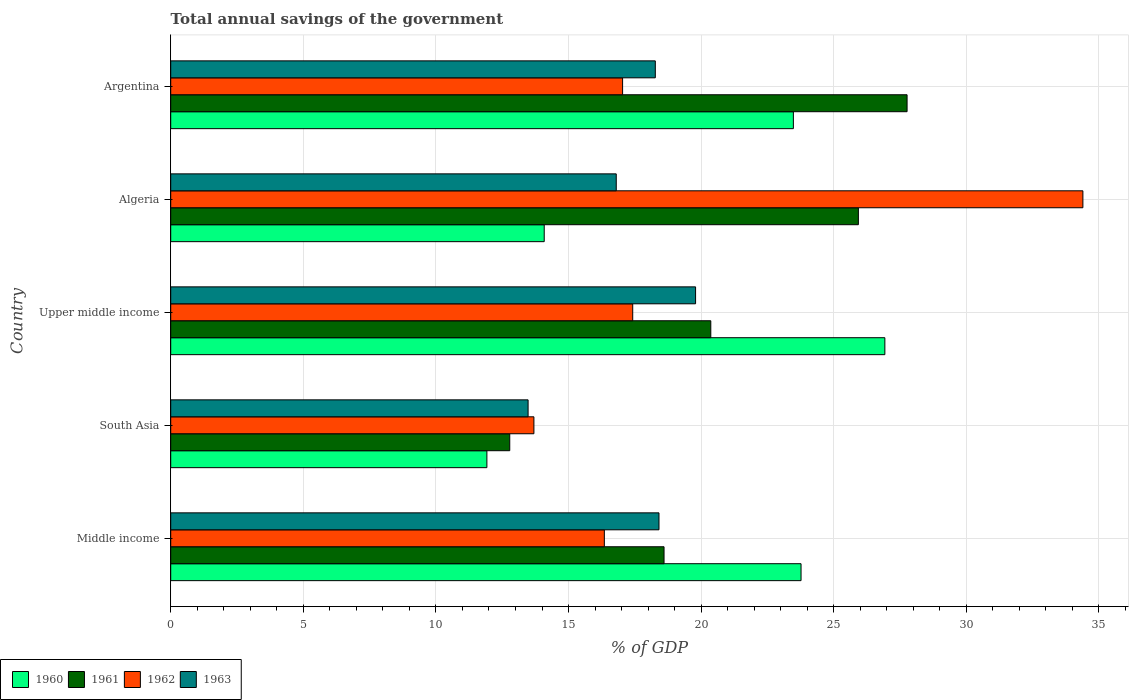Are the number of bars on each tick of the Y-axis equal?
Make the answer very short. Yes. How many bars are there on the 3rd tick from the top?
Give a very brief answer. 4. How many bars are there on the 4th tick from the bottom?
Your answer should be very brief. 4. What is the label of the 3rd group of bars from the top?
Your answer should be very brief. Upper middle income. What is the total annual savings of the government in 1961 in Upper middle income?
Offer a very short reply. 20.37. Across all countries, what is the maximum total annual savings of the government in 1961?
Make the answer very short. 27.77. Across all countries, what is the minimum total annual savings of the government in 1962?
Your answer should be compact. 13.69. In which country was the total annual savings of the government in 1960 maximum?
Offer a very short reply. Upper middle income. In which country was the total annual savings of the government in 1963 minimum?
Give a very brief answer. South Asia. What is the total total annual savings of the government in 1962 in the graph?
Keep it short and to the point. 98.9. What is the difference between the total annual savings of the government in 1963 in Algeria and that in Argentina?
Give a very brief answer. -1.47. What is the difference between the total annual savings of the government in 1963 in South Asia and the total annual savings of the government in 1962 in Middle income?
Keep it short and to the point. -2.88. What is the average total annual savings of the government in 1961 per country?
Provide a succinct answer. 21.09. What is the difference between the total annual savings of the government in 1960 and total annual savings of the government in 1961 in Upper middle income?
Your answer should be compact. 6.56. In how many countries, is the total annual savings of the government in 1960 greater than 7 %?
Offer a terse response. 5. What is the ratio of the total annual savings of the government in 1963 in Argentina to that in Middle income?
Make the answer very short. 0.99. Is the total annual savings of the government in 1961 in Algeria less than that in Middle income?
Ensure brevity in your answer.  No. What is the difference between the highest and the second highest total annual savings of the government in 1962?
Offer a very short reply. 16.97. What is the difference between the highest and the lowest total annual savings of the government in 1961?
Give a very brief answer. 14.98. In how many countries, is the total annual savings of the government in 1962 greater than the average total annual savings of the government in 1962 taken over all countries?
Make the answer very short. 1. Is the sum of the total annual savings of the government in 1963 in Argentina and Middle income greater than the maximum total annual savings of the government in 1962 across all countries?
Ensure brevity in your answer.  Yes. What does the 3rd bar from the top in Upper middle income represents?
Provide a short and direct response. 1961. Is it the case that in every country, the sum of the total annual savings of the government in 1960 and total annual savings of the government in 1963 is greater than the total annual savings of the government in 1962?
Your response must be concise. No. How many countries are there in the graph?
Your response must be concise. 5. Are the values on the major ticks of X-axis written in scientific E-notation?
Give a very brief answer. No. Does the graph contain any zero values?
Your response must be concise. No. Does the graph contain grids?
Your response must be concise. Yes. Where does the legend appear in the graph?
Offer a terse response. Bottom left. What is the title of the graph?
Make the answer very short. Total annual savings of the government. What is the label or title of the X-axis?
Your answer should be compact. % of GDP. What is the % of GDP in 1960 in Middle income?
Your response must be concise. 23.77. What is the % of GDP of 1961 in Middle income?
Your answer should be very brief. 18.6. What is the % of GDP of 1962 in Middle income?
Offer a terse response. 16.35. What is the % of GDP in 1963 in Middle income?
Give a very brief answer. 18.41. What is the % of GDP in 1960 in South Asia?
Keep it short and to the point. 11.92. What is the % of GDP in 1961 in South Asia?
Keep it short and to the point. 12.78. What is the % of GDP in 1962 in South Asia?
Ensure brevity in your answer.  13.69. What is the % of GDP of 1963 in South Asia?
Your response must be concise. 13.48. What is the % of GDP of 1960 in Upper middle income?
Your answer should be very brief. 26.93. What is the % of GDP in 1961 in Upper middle income?
Offer a terse response. 20.37. What is the % of GDP in 1962 in Upper middle income?
Your response must be concise. 17.42. What is the % of GDP of 1963 in Upper middle income?
Ensure brevity in your answer.  19.79. What is the % of GDP of 1960 in Algeria?
Keep it short and to the point. 14.08. What is the % of GDP in 1961 in Algeria?
Provide a succinct answer. 25.93. What is the % of GDP of 1962 in Algeria?
Your answer should be very brief. 34.4. What is the % of GDP of 1963 in Algeria?
Offer a terse response. 16.8. What is the % of GDP in 1960 in Argentina?
Keep it short and to the point. 23.48. What is the % of GDP in 1961 in Argentina?
Your answer should be compact. 27.77. What is the % of GDP in 1962 in Argentina?
Make the answer very short. 17.04. What is the % of GDP of 1963 in Argentina?
Give a very brief answer. 18.27. Across all countries, what is the maximum % of GDP of 1960?
Give a very brief answer. 26.93. Across all countries, what is the maximum % of GDP in 1961?
Your answer should be compact. 27.77. Across all countries, what is the maximum % of GDP in 1962?
Your response must be concise. 34.4. Across all countries, what is the maximum % of GDP of 1963?
Offer a terse response. 19.79. Across all countries, what is the minimum % of GDP in 1960?
Offer a very short reply. 11.92. Across all countries, what is the minimum % of GDP of 1961?
Give a very brief answer. 12.78. Across all countries, what is the minimum % of GDP in 1962?
Offer a very short reply. 13.69. Across all countries, what is the minimum % of GDP in 1963?
Your response must be concise. 13.48. What is the total % of GDP of 1960 in the graph?
Keep it short and to the point. 100.18. What is the total % of GDP of 1961 in the graph?
Give a very brief answer. 105.45. What is the total % of GDP of 1962 in the graph?
Provide a succinct answer. 98.9. What is the total % of GDP in 1963 in the graph?
Make the answer very short. 86.75. What is the difference between the % of GDP of 1960 in Middle income and that in South Asia?
Ensure brevity in your answer.  11.85. What is the difference between the % of GDP in 1961 in Middle income and that in South Asia?
Offer a very short reply. 5.82. What is the difference between the % of GDP in 1962 in Middle income and that in South Asia?
Offer a terse response. 2.66. What is the difference between the % of GDP of 1963 in Middle income and that in South Asia?
Your answer should be compact. 4.94. What is the difference between the % of GDP in 1960 in Middle income and that in Upper middle income?
Keep it short and to the point. -3.16. What is the difference between the % of GDP of 1961 in Middle income and that in Upper middle income?
Keep it short and to the point. -1.76. What is the difference between the % of GDP of 1962 in Middle income and that in Upper middle income?
Make the answer very short. -1.07. What is the difference between the % of GDP in 1963 in Middle income and that in Upper middle income?
Provide a short and direct response. -1.38. What is the difference between the % of GDP in 1960 in Middle income and that in Algeria?
Your answer should be compact. 9.68. What is the difference between the % of GDP of 1961 in Middle income and that in Algeria?
Offer a very short reply. -7.33. What is the difference between the % of GDP in 1962 in Middle income and that in Algeria?
Offer a very short reply. -18.05. What is the difference between the % of GDP of 1963 in Middle income and that in Algeria?
Offer a very short reply. 1.61. What is the difference between the % of GDP of 1960 in Middle income and that in Argentina?
Offer a terse response. 0.29. What is the difference between the % of GDP of 1961 in Middle income and that in Argentina?
Offer a very short reply. -9.16. What is the difference between the % of GDP of 1962 in Middle income and that in Argentina?
Your response must be concise. -0.69. What is the difference between the % of GDP in 1963 in Middle income and that in Argentina?
Your response must be concise. 0.14. What is the difference between the % of GDP of 1960 in South Asia and that in Upper middle income?
Your answer should be compact. -15.01. What is the difference between the % of GDP of 1961 in South Asia and that in Upper middle income?
Offer a very short reply. -7.58. What is the difference between the % of GDP of 1962 in South Asia and that in Upper middle income?
Your answer should be compact. -3.73. What is the difference between the % of GDP in 1963 in South Asia and that in Upper middle income?
Offer a terse response. -6.32. What is the difference between the % of GDP in 1960 in South Asia and that in Algeria?
Keep it short and to the point. -2.16. What is the difference between the % of GDP of 1961 in South Asia and that in Algeria?
Your response must be concise. -13.15. What is the difference between the % of GDP of 1962 in South Asia and that in Algeria?
Your answer should be compact. -20.7. What is the difference between the % of GDP of 1963 in South Asia and that in Algeria?
Ensure brevity in your answer.  -3.32. What is the difference between the % of GDP in 1960 in South Asia and that in Argentina?
Your answer should be very brief. -11.56. What is the difference between the % of GDP of 1961 in South Asia and that in Argentina?
Provide a succinct answer. -14.98. What is the difference between the % of GDP in 1962 in South Asia and that in Argentina?
Provide a short and direct response. -3.34. What is the difference between the % of GDP in 1963 in South Asia and that in Argentina?
Give a very brief answer. -4.8. What is the difference between the % of GDP of 1960 in Upper middle income and that in Algeria?
Make the answer very short. 12.84. What is the difference between the % of GDP of 1961 in Upper middle income and that in Algeria?
Keep it short and to the point. -5.57. What is the difference between the % of GDP in 1962 in Upper middle income and that in Algeria?
Keep it short and to the point. -16.97. What is the difference between the % of GDP in 1963 in Upper middle income and that in Algeria?
Your answer should be compact. 2.99. What is the difference between the % of GDP in 1960 in Upper middle income and that in Argentina?
Provide a short and direct response. 3.45. What is the difference between the % of GDP in 1961 in Upper middle income and that in Argentina?
Provide a succinct answer. -7.4. What is the difference between the % of GDP in 1962 in Upper middle income and that in Argentina?
Your response must be concise. 0.38. What is the difference between the % of GDP of 1963 in Upper middle income and that in Argentina?
Provide a short and direct response. 1.52. What is the difference between the % of GDP of 1960 in Algeria and that in Argentina?
Offer a terse response. -9.4. What is the difference between the % of GDP in 1961 in Algeria and that in Argentina?
Make the answer very short. -1.84. What is the difference between the % of GDP of 1962 in Algeria and that in Argentina?
Provide a short and direct response. 17.36. What is the difference between the % of GDP of 1963 in Algeria and that in Argentina?
Ensure brevity in your answer.  -1.47. What is the difference between the % of GDP in 1960 in Middle income and the % of GDP in 1961 in South Asia?
Your response must be concise. 10.98. What is the difference between the % of GDP in 1960 in Middle income and the % of GDP in 1962 in South Asia?
Provide a short and direct response. 10.07. What is the difference between the % of GDP in 1960 in Middle income and the % of GDP in 1963 in South Asia?
Your answer should be compact. 10.29. What is the difference between the % of GDP in 1961 in Middle income and the % of GDP in 1962 in South Asia?
Your response must be concise. 4.91. What is the difference between the % of GDP of 1961 in Middle income and the % of GDP of 1963 in South Asia?
Keep it short and to the point. 5.13. What is the difference between the % of GDP in 1962 in Middle income and the % of GDP in 1963 in South Asia?
Provide a succinct answer. 2.88. What is the difference between the % of GDP of 1960 in Middle income and the % of GDP of 1961 in Upper middle income?
Provide a succinct answer. 3.4. What is the difference between the % of GDP of 1960 in Middle income and the % of GDP of 1962 in Upper middle income?
Offer a terse response. 6.35. What is the difference between the % of GDP of 1960 in Middle income and the % of GDP of 1963 in Upper middle income?
Offer a very short reply. 3.98. What is the difference between the % of GDP of 1961 in Middle income and the % of GDP of 1962 in Upper middle income?
Provide a short and direct response. 1.18. What is the difference between the % of GDP in 1961 in Middle income and the % of GDP in 1963 in Upper middle income?
Your answer should be very brief. -1.19. What is the difference between the % of GDP of 1962 in Middle income and the % of GDP of 1963 in Upper middle income?
Your response must be concise. -3.44. What is the difference between the % of GDP in 1960 in Middle income and the % of GDP in 1961 in Algeria?
Make the answer very short. -2.16. What is the difference between the % of GDP in 1960 in Middle income and the % of GDP in 1962 in Algeria?
Give a very brief answer. -10.63. What is the difference between the % of GDP in 1960 in Middle income and the % of GDP in 1963 in Algeria?
Offer a very short reply. 6.97. What is the difference between the % of GDP of 1961 in Middle income and the % of GDP of 1962 in Algeria?
Offer a very short reply. -15.79. What is the difference between the % of GDP in 1961 in Middle income and the % of GDP in 1963 in Algeria?
Provide a succinct answer. 1.8. What is the difference between the % of GDP in 1962 in Middle income and the % of GDP in 1963 in Algeria?
Offer a very short reply. -0.45. What is the difference between the % of GDP of 1960 in Middle income and the % of GDP of 1961 in Argentina?
Provide a succinct answer. -4. What is the difference between the % of GDP of 1960 in Middle income and the % of GDP of 1962 in Argentina?
Provide a short and direct response. 6.73. What is the difference between the % of GDP of 1960 in Middle income and the % of GDP of 1963 in Argentina?
Offer a terse response. 5.5. What is the difference between the % of GDP of 1961 in Middle income and the % of GDP of 1962 in Argentina?
Provide a succinct answer. 1.56. What is the difference between the % of GDP of 1961 in Middle income and the % of GDP of 1963 in Argentina?
Give a very brief answer. 0.33. What is the difference between the % of GDP of 1962 in Middle income and the % of GDP of 1963 in Argentina?
Offer a very short reply. -1.92. What is the difference between the % of GDP of 1960 in South Asia and the % of GDP of 1961 in Upper middle income?
Keep it short and to the point. -8.44. What is the difference between the % of GDP of 1960 in South Asia and the % of GDP of 1962 in Upper middle income?
Your answer should be very brief. -5.5. What is the difference between the % of GDP in 1960 in South Asia and the % of GDP in 1963 in Upper middle income?
Your answer should be compact. -7.87. What is the difference between the % of GDP of 1961 in South Asia and the % of GDP of 1962 in Upper middle income?
Offer a terse response. -4.64. What is the difference between the % of GDP in 1961 in South Asia and the % of GDP in 1963 in Upper middle income?
Ensure brevity in your answer.  -7.01. What is the difference between the % of GDP of 1962 in South Asia and the % of GDP of 1963 in Upper middle income?
Provide a short and direct response. -6.1. What is the difference between the % of GDP in 1960 in South Asia and the % of GDP in 1961 in Algeria?
Provide a succinct answer. -14.01. What is the difference between the % of GDP of 1960 in South Asia and the % of GDP of 1962 in Algeria?
Your answer should be very brief. -22.47. What is the difference between the % of GDP in 1960 in South Asia and the % of GDP in 1963 in Algeria?
Provide a succinct answer. -4.88. What is the difference between the % of GDP of 1961 in South Asia and the % of GDP of 1962 in Algeria?
Your answer should be very brief. -21.61. What is the difference between the % of GDP in 1961 in South Asia and the % of GDP in 1963 in Algeria?
Your answer should be compact. -4.02. What is the difference between the % of GDP in 1962 in South Asia and the % of GDP in 1963 in Algeria?
Ensure brevity in your answer.  -3.1. What is the difference between the % of GDP in 1960 in South Asia and the % of GDP in 1961 in Argentina?
Offer a terse response. -15.84. What is the difference between the % of GDP in 1960 in South Asia and the % of GDP in 1962 in Argentina?
Ensure brevity in your answer.  -5.12. What is the difference between the % of GDP in 1960 in South Asia and the % of GDP in 1963 in Argentina?
Your answer should be compact. -6.35. What is the difference between the % of GDP in 1961 in South Asia and the % of GDP in 1962 in Argentina?
Ensure brevity in your answer.  -4.26. What is the difference between the % of GDP of 1961 in South Asia and the % of GDP of 1963 in Argentina?
Offer a terse response. -5.49. What is the difference between the % of GDP in 1962 in South Asia and the % of GDP in 1963 in Argentina?
Your answer should be very brief. -4.58. What is the difference between the % of GDP in 1960 in Upper middle income and the % of GDP in 1962 in Algeria?
Keep it short and to the point. -7.47. What is the difference between the % of GDP of 1960 in Upper middle income and the % of GDP of 1963 in Algeria?
Your answer should be very brief. 10.13. What is the difference between the % of GDP of 1961 in Upper middle income and the % of GDP of 1962 in Algeria?
Give a very brief answer. -14.03. What is the difference between the % of GDP in 1961 in Upper middle income and the % of GDP in 1963 in Algeria?
Your response must be concise. 3.57. What is the difference between the % of GDP in 1962 in Upper middle income and the % of GDP in 1963 in Algeria?
Ensure brevity in your answer.  0.62. What is the difference between the % of GDP of 1960 in Upper middle income and the % of GDP of 1961 in Argentina?
Offer a very short reply. -0.84. What is the difference between the % of GDP of 1960 in Upper middle income and the % of GDP of 1962 in Argentina?
Keep it short and to the point. 9.89. What is the difference between the % of GDP of 1960 in Upper middle income and the % of GDP of 1963 in Argentina?
Ensure brevity in your answer.  8.66. What is the difference between the % of GDP in 1961 in Upper middle income and the % of GDP in 1962 in Argentina?
Ensure brevity in your answer.  3.33. What is the difference between the % of GDP in 1961 in Upper middle income and the % of GDP in 1963 in Argentina?
Offer a terse response. 2.09. What is the difference between the % of GDP of 1962 in Upper middle income and the % of GDP of 1963 in Argentina?
Your response must be concise. -0.85. What is the difference between the % of GDP of 1960 in Algeria and the % of GDP of 1961 in Argentina?
Offer a very short reply. -13.68. What is the difference between the % of GDP in 1960 in Algeria and the % of GDP in 1962 in Argentina?
Offer a very short reply. -2.96. What is the difference between the % of GDP of 1960 in Algeria and the % of GDP of 1963 in Argentina?
Give a very brief answer. -4.19. What is the difference between the % of GDP in 1961 in Algeria and the % of GDP in 1962 in Argentina?
Give a very brief answer. 8.89. What is the difference between the % of GDP in 1961 in Algeria and the % of GDP in 1963 in Argentina?
Offer a terse response. 7.66. What is the difference between the % of GDP of 1962 in Algeria and the % of GDP of 1963 in Argentina?
Offer a terse response. 16.12. What is the average % of GDP of 1960 per country?
Offer a very short reply. 20.04. What is the average % of GDP in 1961 per country?
Your answer should be compact. 21.09. What is the average % of GDP in 1962 per country?
Your response must be concise. 19.78. What is the average % of GDP of 1963 per country?
Give a very brief answer. 17.35. What is the difference between the % of GDP of 1960 and % of GDP of 1961 in Middle income?
Give a very brief answer. 5.17. What is the difference between the % of GDP in 1960 and % of GDP in 1962 in Middle income?
Give a very brief answer. 7.42. What is the difference between the % of GDP in 1960 and % of GDP in 1963 in Middle income?
Make the answer very short. 5.36. What is the difference between the % of GDP of 1961 and % of GDP of 1962 in Middle income?
Offer a terse response. 2.25. What is the difference between the % of GDP in 1961 and % of GDP in 1963 in Middle income?
Ensure brevity in your answer.  0.19. What is the difference between the % of GDP in 1962 and % of GDP in 1963 in Middle income?
Give a very brief answer. -2.06. What is the difference between the % of GDP of 1960 and % of GDP of 1961 in South Asia?
Give a very brief answer. -0.86. What is the difference between the % of GDP in 1960 and % of GDP in 1962 in South Asia?
Your response must be concise. -1.77. What is the difference between the % of GDP of 1960 and % of GDP of 1963 in South Asia?
Provide a succinct answer. -1.55. What is the difference between the % of GDP in 1961 and % of GDP in 1962 in South Asia?
Offer a very short reply. -0.91. What is the difference between the % of GDP in 1961 and % of GDP in 1963 in South Asia?
Offer a terse response. -0.69. What is the difference between the % of GDP in 1962 and % of GDP in 1963 in South Asia?
Your answer should be very brief. 0.22. What is the difference between the % of GDP in 1960 and % of GDP in 1961 in Upper middle income?
Your answer should be very brief. 6.56. What is the difference between the % of GDP of 1960 and % of GDP of 1962 in Upper middle income?
Keep it short and to the point. 9.51. What is the difference between the % of GDP in 1960 and % of GDP in 1963 in Upper middle income?
Make the answer very short. 7.14. What is the difference between the % of GDP of 1961 and % of GDP of 1962 in Upper middle income?
Your response must be concise. 2.94. What is the difference between the % of GDP of 1961 and % of GDP of 1963 in Upper middle income?
Your answer should be very brief. 0.57. What is the difference between the % of GDP of 1962 and % of GDP of 1963 in Upper middle income?
Your answer should be very brief. -2.37. What is the difference between the % of GDP in 1960 and % of GDP in 1961 in Algeria?
Offer a terse response. -11.85. What is the difference between the % of GDP of 1960 and % of GDP of 1962 in Algeria?
Your answer should be compact. -20.31. What is the difference between the % of GDP of 1960 and % of GDP of 1963 in Algeria?
Offer a very short reply. -2.72. What is the difference between the % of GDP of 1961 and % of GDP of 1962 in Algeria?
Your response must be concise. -8.47. What is the difference between the % of GDP of 1961 and % of GDP of 1963 in Algeria?
Provide a short and direct response. 9.13. What is the difference between the % of GDP in 1962 and % of GDP in 1963 in Algeria?
Offer a very short reply. 17.6. What is the difference between the % of GDP in 1960 and % of GDP in 1961 in Argentina?
Give a very brief answer. -4.29. What is the difference between the % of GDP of 1960 and % of GDP of 1962 in Argentina?
Offer a terse response. 6.44. What is the difference between the % of GDP in 1960 and % of GDP in 1963 in Argentina?
Your answer should be very brief. 5.21. What is the difference between the % of GDP in 1961 and % of GDP in 1962 in Argentina?
Ensure brevity in your answer.  10.73. What is the difference between the % of GDP in 1961 and % of GDP in 1963 in Argentina?
Give a very brief answer. 9.49. What is the difference between the % of GDP in 1962 and % of GDP in 1963 in Argentina?
Ensure brevity in your answer.  -1.23. What is the ratio of the % of GDP of 1960 in Middle income to that in South Asia?
Provide a short and direct response. 1.99. What is the ratio of the % of GDP in 1961 in Middle income to that in South Asia?
Offer a very short reply. 1.46. What is the ratio of the % of GDP of 1962 in Middle income to that in South Asia?
Make the answer very short. 1.19. What is the ratio of the % of GDP in 1963 in Middle income to that in South Asia?
Your answer should be compact. 1.37. What is the ratio of the % of GDP in 1960 in Middle income to that in Upper middle income?
Your answer should be compact. 0.88. What is the ratio of the % of GDP of 1961 in Middle income to that in Upper middle income?
Make the answer very short. 0.91. What is the ratio of the % of GDP of 1962 in Middle income to that in Upper middle income?
Offer a very short reply. 0.94. What is the ratio of the % of GDP in 1963 in Middle income to that in Upper middle income?
Ensure brevity in your answer.  0.93. What is the ratio of the % of GDP of 1960 in Middle income to that in Algeria?
Your answer should be very brief. 1.69. What is the ratio of the % of GDP in 1961 in Middle income to that in Algeria?
Give a very brief answer. 0.72. What is the ratio of the % of GDP in 1962 in Middle income to that in Algeria?
Keep it short and to the point. 0.48. What is the ratio of the % of GDP in 1963 in Middle income to that in Algeria?
Offer a very short reply. 1.1. What is the ratio of the % of GDP in 1960 in Middle income to that in Argentina?
Keep it short and to the point. 1.01. What is the ratio of the % of GDP in 1961 in Middle income to that in Argentina?
Your answer should be compact. 0.67. What is the ratio of the % of GDP of 1962 in Middle income to that in Argentina?
Provide a succinct answer. 0.96. What is the ratio of the % of GDP of 1963 in Middle income to that in Argentina?
Keep it short and to the point. 1.01. What is the ratio of the % of GDP of 1960 in South Asia to that in Upper middle income?
Provide a succinct answer. 0.44. What is the ratio of the % of GDP in 1961 in South Asia to that in Upper middle income?
Offer a terse response. 0.63. What is the ratio of the % of GDP of 1962 in South Asia to that in Upper middle income?
Offer a terse response. 0.79. What is the ratio of the % of GDP in 1963 in South Asia to that in Upper middle income?
Provide a short and direct response. 0.68. What is the ratio of the % of GDP in 1960 in South Asia to that in Algeria?
Offer a very short reply. 0.85. What is the ratio of the % of GDP of 1961 in South Asia to that in Algeria?
Your response must be concise. 0.49. What is the ratio of the % of GDP of 1962 in South Asia to that in Algeria?
Your answer should be very brief. 0.4. What is the ratio of the % of GDP in 1963 in South Asia to that in Algeria?
Your answer should be compact. 0.8. What is the ratio of the % of GDP in 1960 in South Asia to that in Argentina?
Your answer should be very brief. 0.51. What is the ratio of the % of GDP of 1961 in South Asia to that in Argentina?
Provide a succinct answer. 0.46. What is the ratio of the % of GDP of 1962 in South Asia to that in Argentina?
Your response must be concise. 0.8. What is the ratio of the % of GDP in 1963 in South Asia to that in Argentina?
Provide a short and direct response. 0.74. What is the ratio of the % of GDP of 1960 in Upper middle income to that in Algeria?
Make the answer very short. 1.91. What is the ratio of the % of GDP in 1961 in Upper middle income to that in Algeria?
Keep it short and to the point. 0.79. What is the ratio of the % of GDP of 1962 in Upper middle income to that in Algeria?
Provide a succinct answer. 0.51. What is the ratio of the % of GDP of 1963 in Upper middle income to that in Algeria?
Make the answer very short. 1.18. What is the ratio of the % of GDP of 1960 in Upper middle income to that in Argentina?
Provide a succinct answer. 1.15. What is the ratio of the % of GDP in 1961 in Upper middle income to that in Argentina?
Your answer should be very brief. 0.73. What is the ratio of the % of GDP of 1962 in Upper middle income to that in Argentina?
Offer a terse response. 1.02. What is the ratio of the % of GDP of 1963 in Upper middle income to that in Argentina?
Provide a short and direct response. 1.08. What is the ratio of the % of GDP in 1960 in Algeria to that in Argentina?
Provide a short and direct response. 0.6. What is the ratio of the % of GDP in 1961 in Algeria to that in Argentina?
Give a very brief answer. 0.93. What is the ratio of the % of GDP in 1962 in Algeria to that in Argentina?
Make the answer very short. 2.02. What is the ratio of the % of GDP of 1963 in Algeria to that in Argentina?
Your answer should be very brief. 0.92. What is the difference between the highest and the second highest % of GDP in 1960?
Keep it short and to the point. 3.16. What is the difference between the highest and the second highest % of GDP of 1961?
Ensure brevity in your answer.  1.84. What is the difference between the highest and the second highest % of GDP of 1962?
Make the answer very short. 16.97. What is the difference between the highest and the second highest % of GDP of 1963?
Provide a succinct answer. 1.38. What is the difference between the highest and the lowest % of GDP of 1960?
Offer a terse response. 15.01. What is the difference between the highest and the lowest % of GDP of 1961?
Give a very brief answer. 14.98. What is the difference between the highest and the lowest % of GDP of 1962?
Make the answer very short. 20.7. What is the difference between the highest and the lowest % of GDP in 1963?
Provide a succinct answer. 6.32. 